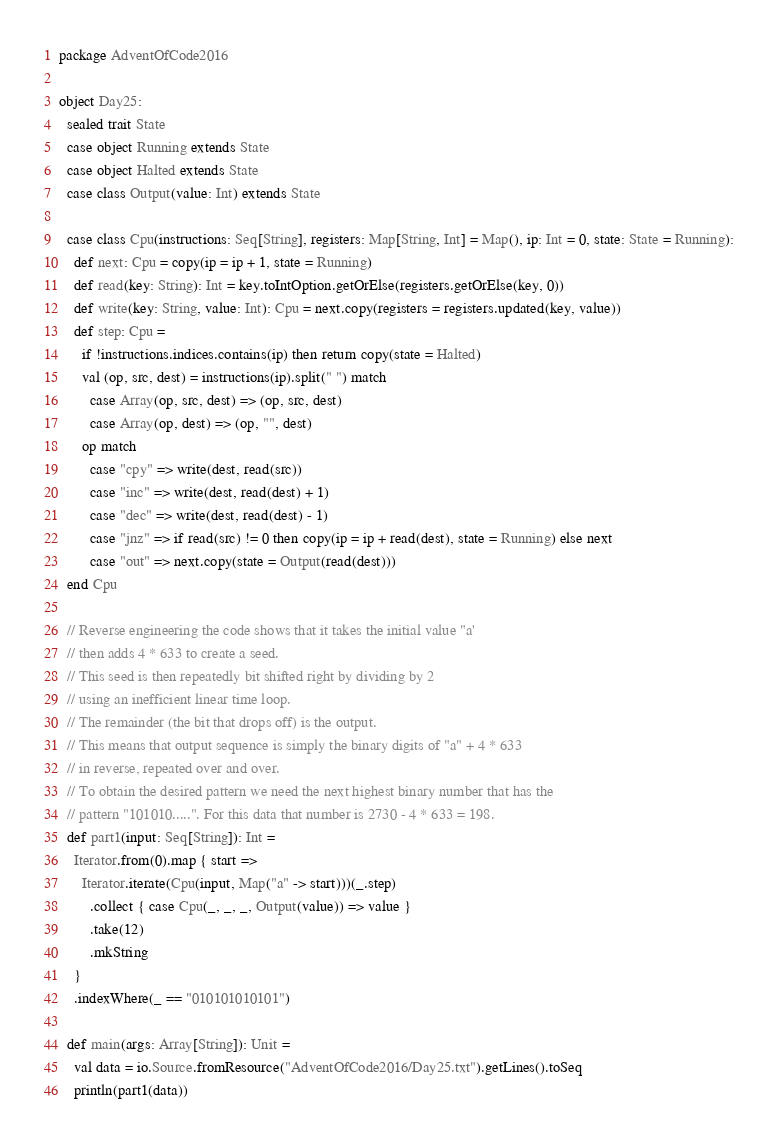Convert code to text. <code><loc_0><loc_0><loc_500><loc_500><_Scala_>package AdventOfCode2016

object Day25:
  sealed trait State
  case object Running extends State
  case object Halted extends State
  case class Output(value: Int) extends State

  case class Cpu(instructions: Seq[String], registers: Map[String, Int] = Map(), ip: Int = 0, state: State = Running):
    def next: Cpu = copy(ip = ip + 1, state = Running)
    def read(key: String): Int = key.toIntOption.getOrElse(registers.getOrElse(key, 0))
    def write(key: String, value: Int): Cpu = next.copy(registers = registers.updated(key, value))
    def step: Cpu =
      if !instructions.indices.contains(ip) then return copy(state = Halted)
      val (op, src, dest) = instructions(ip).split(" ") match
        case Array(op, src, dest) => (op, src, dest)
        case Array(op, dest) => (op, "", dest)
      op match
        case "cpy" => write(dest, read(src))
        case "inc" => write(dest, read(dest) + 1)
        case "dec" => write(dest, read(dest) - 1)
        case "jnz" => if read(src) != 0 then copy(ip = ip + read(dest), state = Running) else next
        case "out" => next.copy(state = Output(read(dest)))
  end Cpu

  // Reverse engineering the code shows that it takes the initial value "a'
  // then adds 4 * 633 to create a seed.
  // This seed is then repeatedly bit shifted right by dividing by 2
  // using an inefficient linear time loop.
  // The remainder (the bit that drops off) is the output.
  // This means that output sequence is simply the binary digits of "a" + 4 * 633
  // in reverse, repeated over and over.
  // To obtain the desired pattern we need the next highest binary number that has the
  // pattern "101010.....". For this data that number is 2730 - 4 * 633 = 198.
  def part1(input: Seq[String]): Int =
    Iterator.from(0).map { start =>
      Iterator.iterate(Cpu(input, Map("a" -> start)))(_.step)
        .collect { case Cpu(_, _, _, Output(value)) => value }
        .take(12)
        .mkString
    }
    .indexWhere(_ == "010101010101")

  def main(args: Array[String]): Unit =
    val data = io.Source.fromResource("AdventOfCode2016/Day25.txt").getLines().toSeq
    println(part1(data))
</code> 